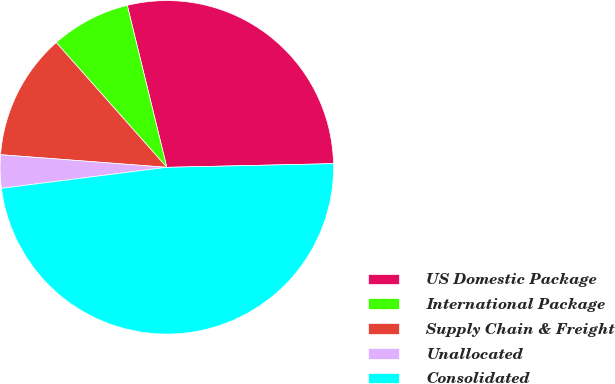Convert chart. <chart><loc_0><loc_0><loc_500><loc_500><pie_chart><fcel>US Domestic Package<fcel>International Package<fcel>Supply Chain & Freight<fcel>Unallocated<fcel>Consolidated<nl><fcel>28.46%<fcel>7.73%<fcel>12.25%<fcel>3.22%<fcel>48.34%<nl></chart> 